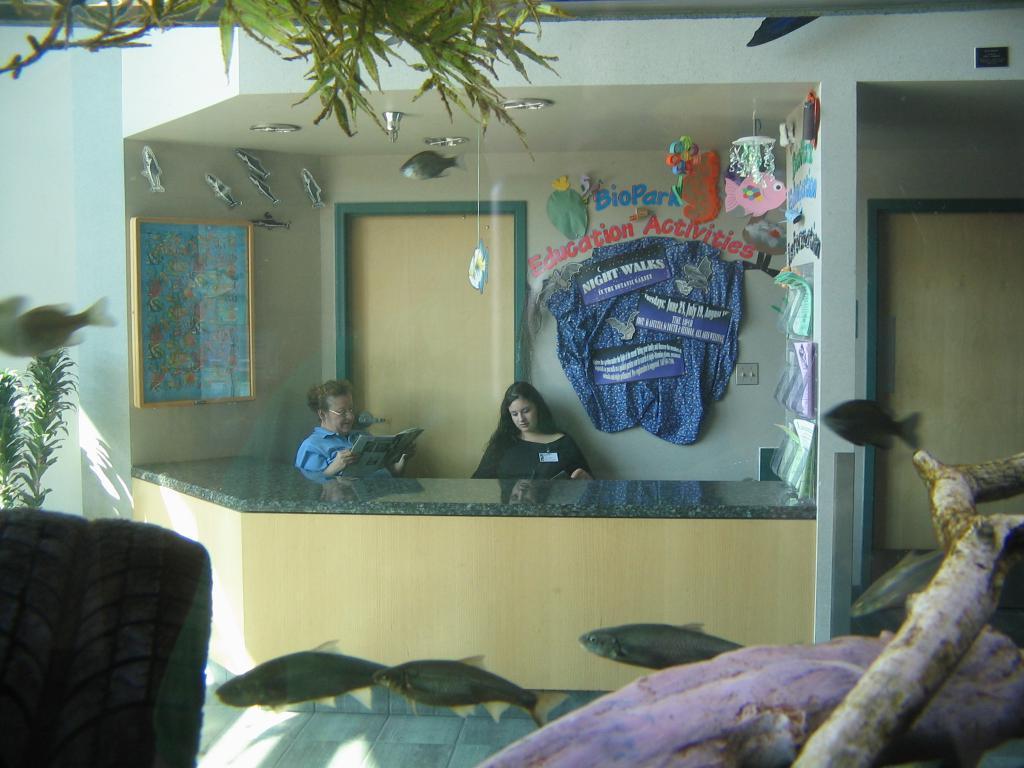Could you give a brief overview of what you see in this image? In the foreground there is a fish tank along with the fishes and leaves in the water. In the background two persons are holding some objects in the hands and sitting. In front of them there is a table. In the background there is a door and also I can see a frame and some other objects are attached to the wall. On the right side there is another door. 